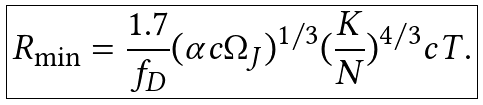Convert formula to latex. <formula><loc_0><loc_0><loc_500><loc_500>\boxed { R _ { \min } = \frac { 1 . 7 } { f _ { D } } ( \alpha c \Omega _ { J } ) ^ { 1 / 3 } ( \frac { K } { N } ) ^ { 4 / 3 } c T . }</formula> 